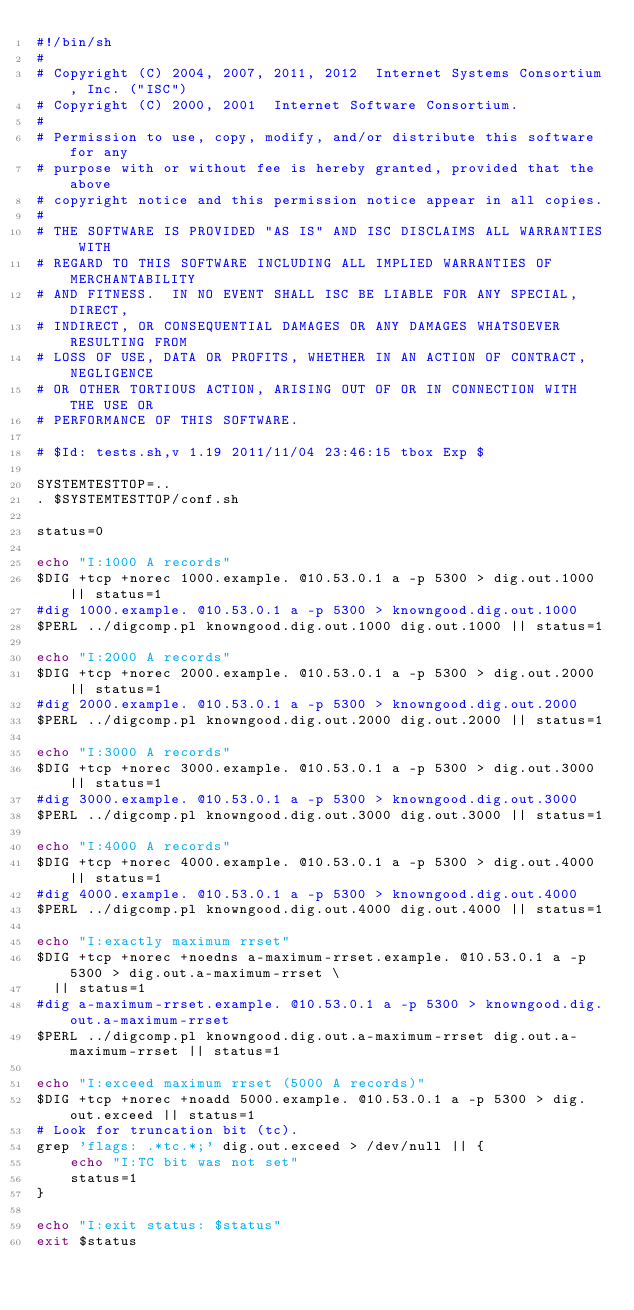Convert code to text. <code><loc_0><loc_0><loc_500><loc_500><_Bash_>#!/bin/sh
#
# Copyright (C) 2004, 2007, 2011, 2012  Internet Systems Consortium, Inc. ("ISC")
# Copyright (C) 2000, 2001  Internet Software Consortium.
#
# Permission to use, copy, modify, and/or distribute this software for any
# purpose with or without fee is hereby granted, provided that the above
# copyright notice and this permission notice appear in all copies.
#
# THE SOFTWARE IS PROVIDED "AS IS" AND ISC DISCLAIMS ALL WARRANTIES WITH
# REGARD TO THIS SOFTWARE INCLUDING ALL IMPLIED WARRANTIES OF MERCHANTABILITY
# AND FITNESS.  IN NO EVENT SHALL ISC BE LIABLE FOR ANY SPECIAL, DIRECT,
# INDIRECT, OR CONSEQUENTIAL DAMAGES OR ANY DAMAGES WHATSOEVER RESULTING FROM
# LOSS OF USE, DATA OR PROFITS, WHETHER IN AN ACTION OF CONTRACT, NEGLIGENCE
# OR OTHER TORTIOUS ACTION, ARISING OUT OF OR IN CONNECTION WITH THE USE OR
# PERFORMANCE OF THIS SOFTWARE.

# $Id: tests.sh,v 1.19 2011/11/04 23:46:15 tbox Exp $

SYSTEMTESTTOP=..
. $SYSTEMTESTTOP/conf.sh

status=0

echo "I:1000 A records"
$DIG +tcp +norec 1000.example. @10.53.0.1 a -p 5300 > dig.out.1000 || status=1
#dig 1000.example. @10.53.0.1 a -p 5300 > knowngood.dig.out.1000
$PERL ../digcomp.pl knowngood.dig.out.1000 dig.out.1000 || status=1

echo "I:2000 A records"
$DIG +tcp +norec 2000.example. @10.53.0.1 a -p 5300 > dig.out.2000 || status=1
#dig 2000.example. @10.53.0.1 a -p 5300 > knowngood.dig.out.2000
$PERL ../digcomp.pl knowngood.dig.out.2000 dig.out.2000 || status=1

echo "I:3000 A records"
$DIG +tcp +norec 3000.example. @10.53.0.1 a -p 5300 > dig.out.3000 || status=1
#dig 3000.example. @10.53.0.1 a -p 5300 > knowngood.dig.out.3000
$PERL ../digcomp.pl knowngood.dig.out.3000 dig.out.3000 || status=1

echo "I:4000 A records"
$DIG +tcp +norec 4000.example. @10.53.0.1 a -p 5300 > dig.out.4000 || status=1
#dig 4000.example. @10.53.0.1 a -p 5300 > knowngood.dig.out.4000
$PERL ../digcomp.pl knowngood.dig.out.4000 dig.out.4000 || status=1

echo "I:exactly maximum rrset"
$DIG +tcp +norec +noedns a-maximum-rrset.example. @10.53.0.1 a -p 5300 > dig.out.a-maximum-rrset \
	|| status=1
#dig a-maximum-rrset.example. @10.53.0.1 a -p 5300 > knowngood.dig.out.a-maximum-rrset
$PERL ../digcomp.pl knowngood.dig.out.a-maximum-rrset dig.out.a-maximum-rrset || status=1

echo "I:exceed maximum rrset (5000 A records)"
$DIG +tcp +norec +noadd 5000.example. @10.53.0.1 a -p 5300 > dig.out.exceed || status=1
# Look for truncation bit (tc).
grep 'flags: .*tc.*;' dig.out.exceed > /dev/null || {
    echo "I:TC bit was not set"
    status=1
}

echo "I:exit status: $status"
exit $status
</code> 